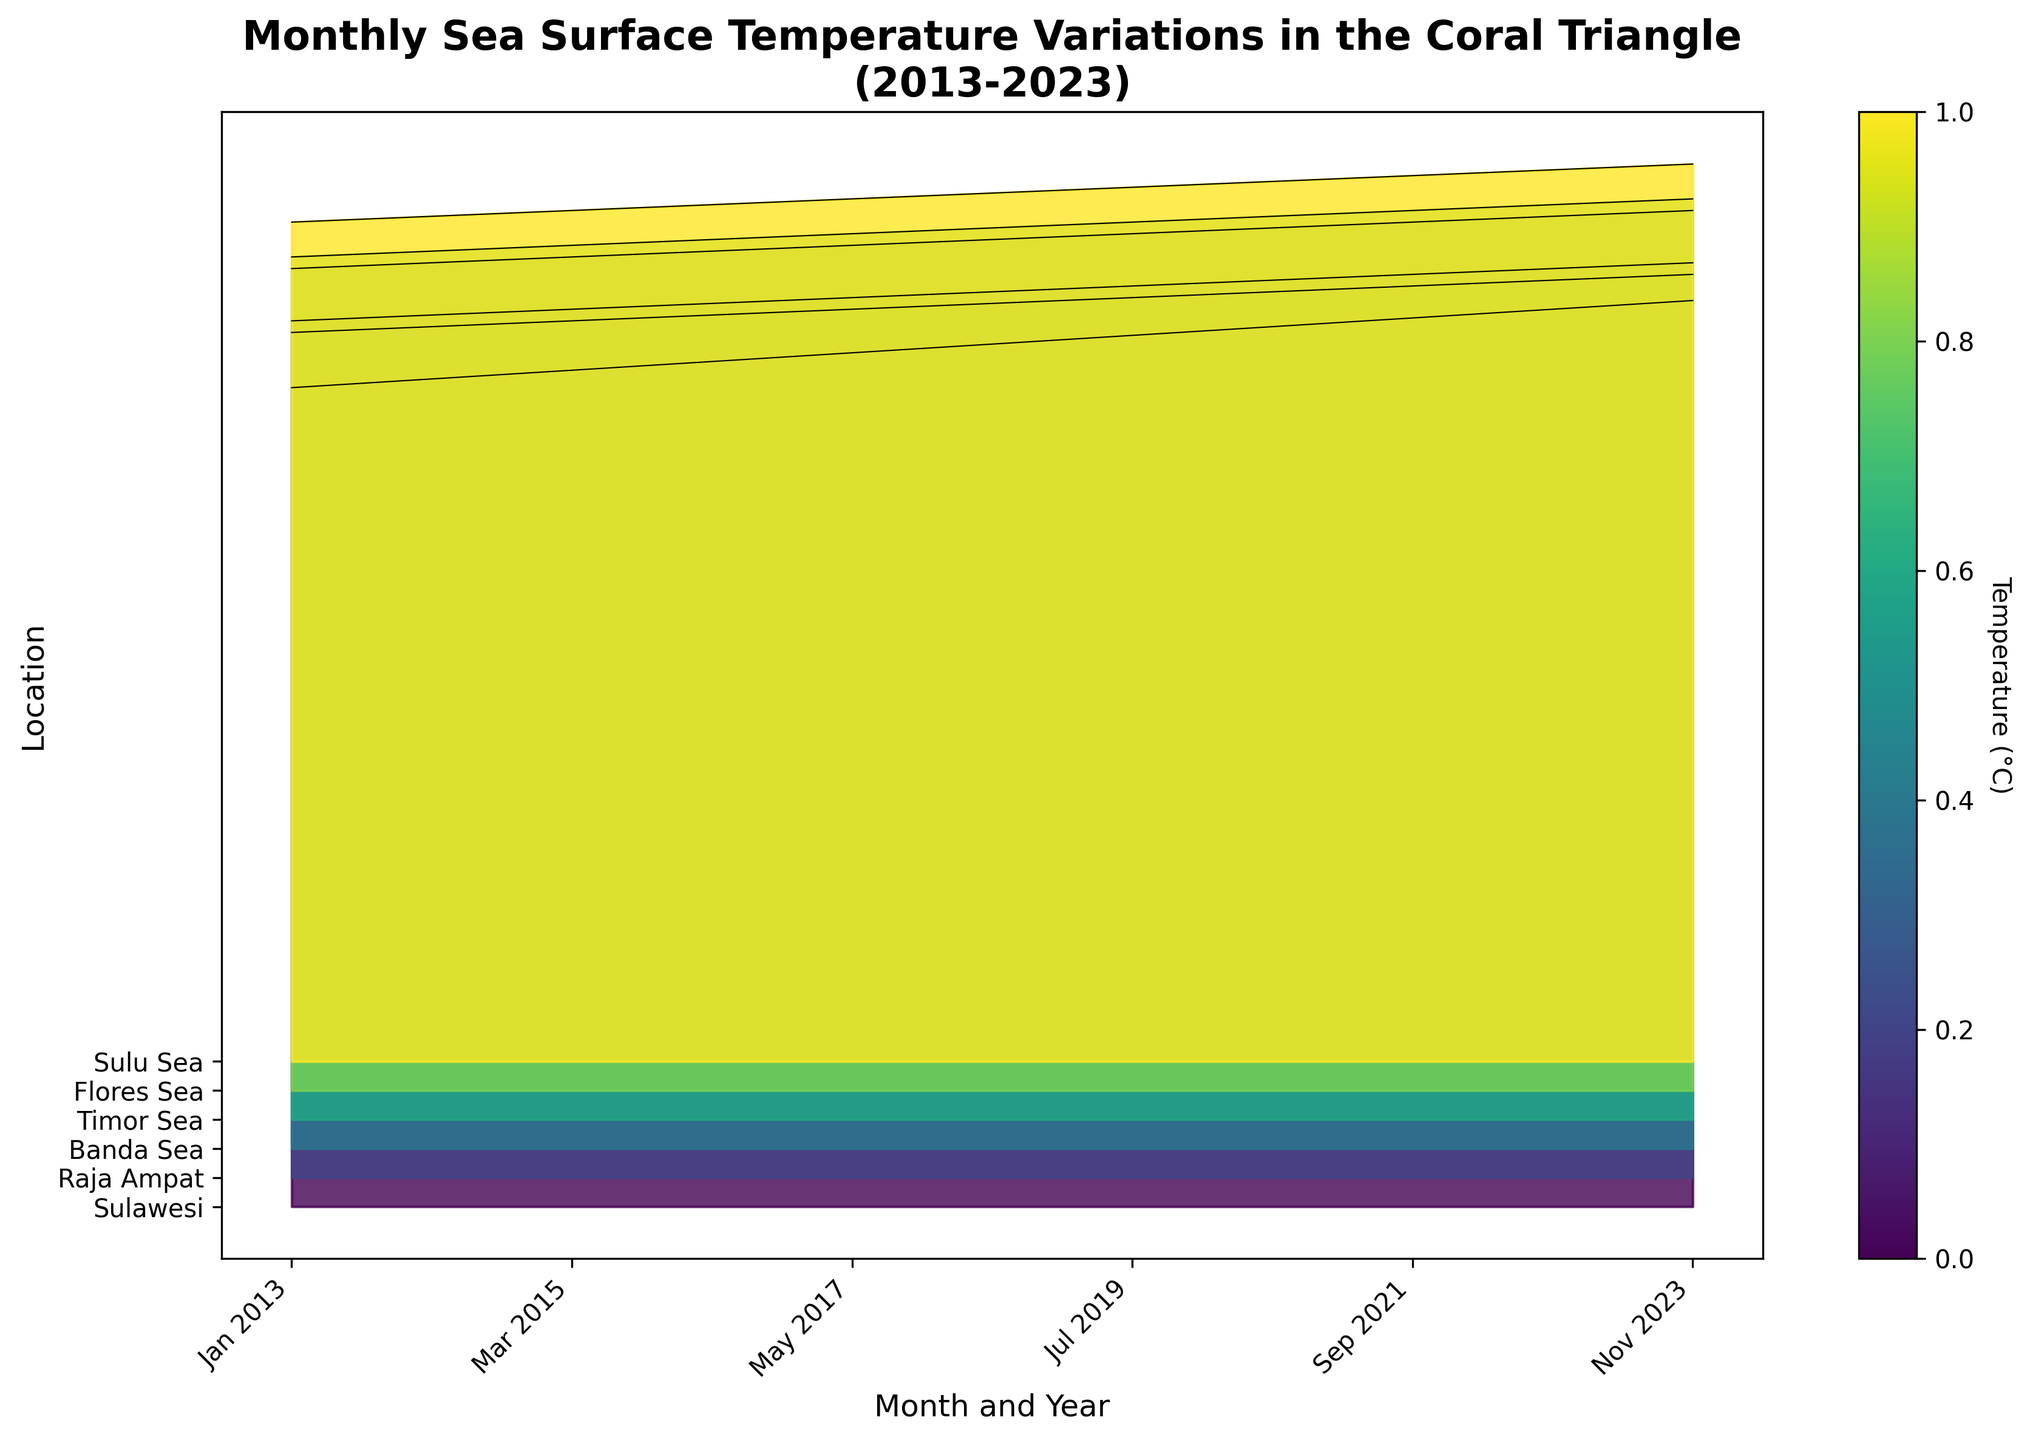Which location has the highest sea surface temperature in Nov 2023? Raja Ampat has the highest sea surface temperature. To determine this, we can observe the ridgeline plot for Nov 2023, where Raja Ampat shows a peak temperature distinctly higher than other locations.
Answer: Raja Ampat What is the overall trend of sea surface temperatures over the decade? The overall trend shows an increase in sea surface temperatures across all locations. By observing the ridgeline plot, one can see that the ridgelines generally increase in height from left to right, indicating rising temperatures over time.
Answer: Increasing Which month and year had the lowest sea surface temperature for Sulawesi? January 2013 has the lowest sea surface temperature for Sulawesi. Looking at Sulawesi’s ridgeline, the lowest point is at the beginning of the plot which corresponds to January 2013.
Answer: January 2013 How do the temperatures of Timor Sea in August 2020 compare to September 2021? Timor Sea has higher temperatures in September 2021 compared to August 2020. Observing the ridgeline plot, September 2021 shows a higher peak than August 2020 for Timor Sea.
Answer: Higher in September 2021 Is there a consistent seasonal pattern identifiable for Raja Ampat? No, a consistent seasonal pattern is not immediately identifiable for Raja Ampat from the ridgeline plot as the temperatures steadily rise over the years without showing any apparent repeating seasonal dips or peaks.
Answer: No What is the relative difference in temperature between Banda Sea and Flores Sea in July 2019? The temperature difference in July 2019 between Banda Sea and Flores Sea is 0.2°C, with Banda Sea being 29.7°C and Flores Sea being 29.9°C. This is obtained by observing the respective heights of the ridgelines in the plot for July 2019.
Answer: 0.2°C Which location showed the most consistent increase in sea surface temperature over the decade? Timor Sea showed the most consistent increase in sea surface temperature. The plot shows a steady rise in temperature for Timor Sea with minimal fluctuations over the years.
Answer: Timor Sea What is the peak temperature recorded for Sulawesi throughout the decade? The peak temperature recorded for Sulawesi is 31.2°C, observed in November 2023. By looking at the Sulawesi ridgeline, the highest peak occurs at the end of the timeline.
Answer: 31.2°C Which year showed a significant temperature rise for the Sulu Sea? A significant temperature rise for the Sulu Sea is observable in 2020. Comparing the ridgelines year-by-year, there is a noticeable increase in the height of the Sulu Sea ridgeline starting from 2020.
Answer: 2020 How have the sea surface temperatures in Flores Sea changed from May 2017 to June 2018? The sea surface temperature in Flores Sea increased from May 2017 (29.5°C) to June 2018 (29.7°C). This can be seen by observing the respective heights of the ridgelines for these months.
Answer: Increased by 0.2°C 